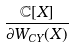Convert formula to latex. <formula><loc_0><loc_0><loc_500><loc_500>\frac { { \mathbb { C } } [ X ] } { \partial W _ { C Y } ( X ) }</formula> 